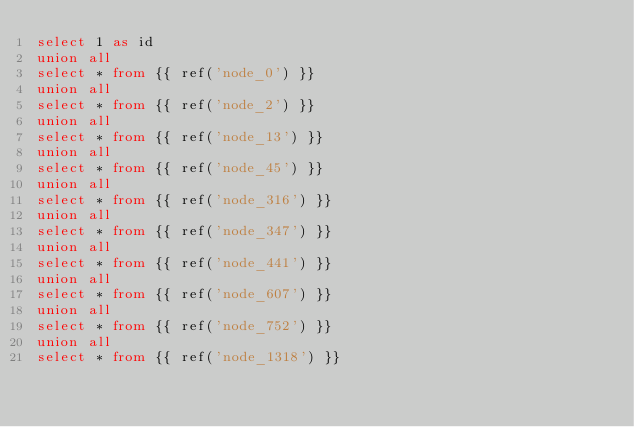Convert code to text. <code><loc_0><loc_0><loc_500><loc_500><_SQL_>select 1 as id
union all
select * from {{ ref('node_0') }}
union all
select * from {{ ref('node_2') }}
union all
select * from {{ ref('node_13') }}
union all
select * from {{ ref('node_45') }}
union all
select * from {{ ref('node_316') }}
union all
select * from {{ ref('node_347') }}
union all
select * from {{ ref('node_441') }}
union all
select * from {{ ref('node_607') }}
union all
select * from {{ ref('node_752') }}
union all
select * from {{ ref('node_1318') }}
</code> 